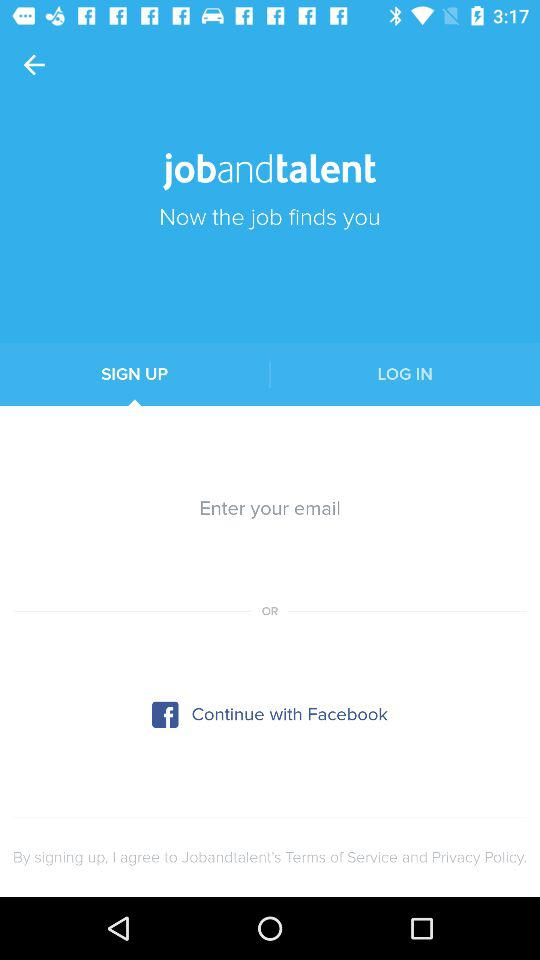By what application can we continue without entering an email? You can continue by clicking "Facebook" without entering an email. 